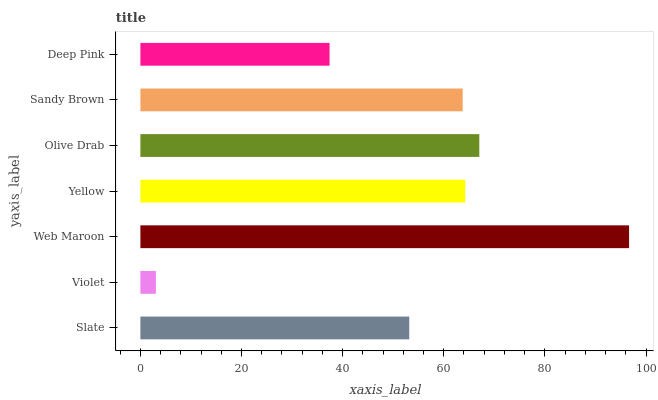Is Violet the minimum?
Answer yes or no. Yes. Is Web Maroon the maximum?
Answer yes or no. Yes. Is Web Maroon the minimum?
Answer yes or no. No. Is Violet the maximum?
Answer yes or no. No. Is Web Maroon greater than Violet?
Answer yes or no. Yes. Is Violet less than Web Maroon?
Answer yes or no. Yes. Is Violet greater than Web Maroon?
Answer yes or no. No. Is Web Maroon less than Violet?
Answer yes or no. No. Is Sandy Brown the high median?
Answer yes or no. Yes. Is Sandy Brown the low median?
Answer yes or no. Yes. Is Web Maroon the high median?
Answer yes or no. No. Is Deep Pink the low median?
Answer yes or no. No. 